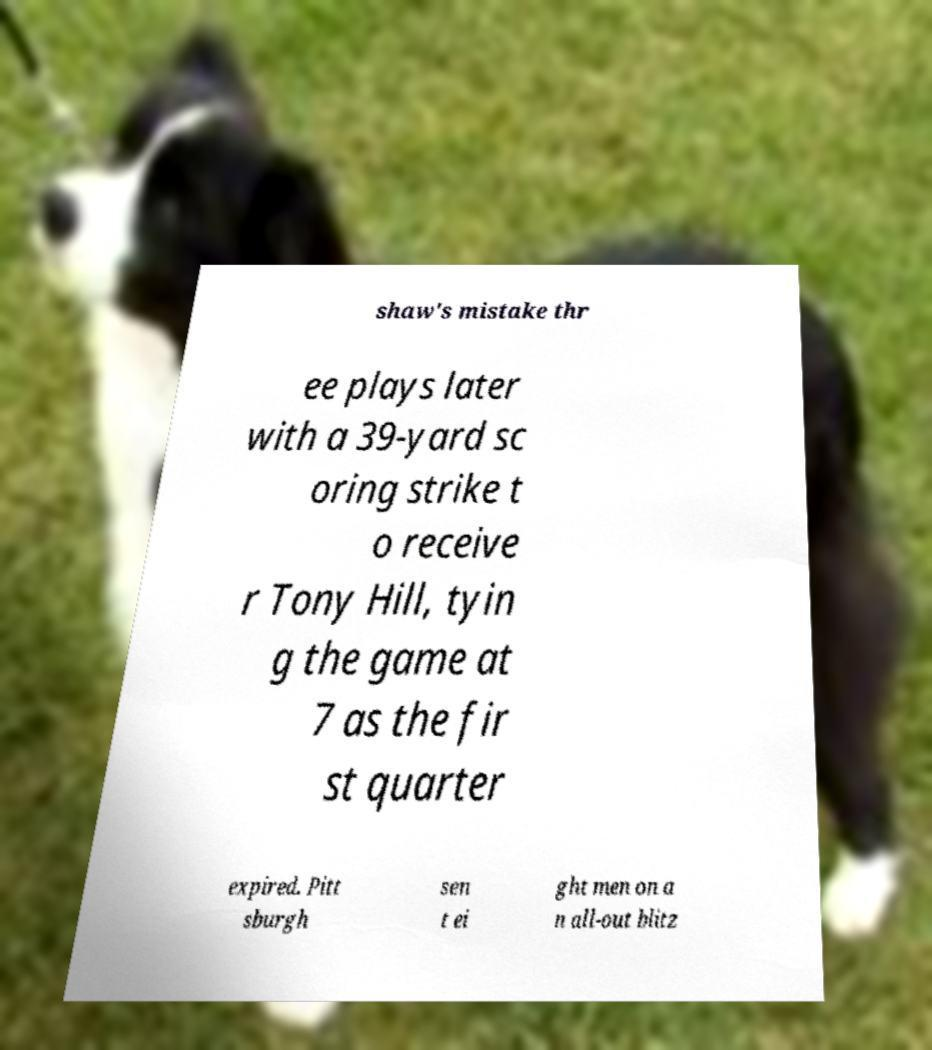Can you read and provide the text displayed in the image?This photo seems to have some interesting text. Can you extract and type it out for me? shaw's mistake thr ee plays later with a 39-yard sc oring strike t o receive r Tony Hill, tyin g the game at 7 as the fir st quarter expired. Pitt sburgh sen t ei ght men on a n all-out blitz 